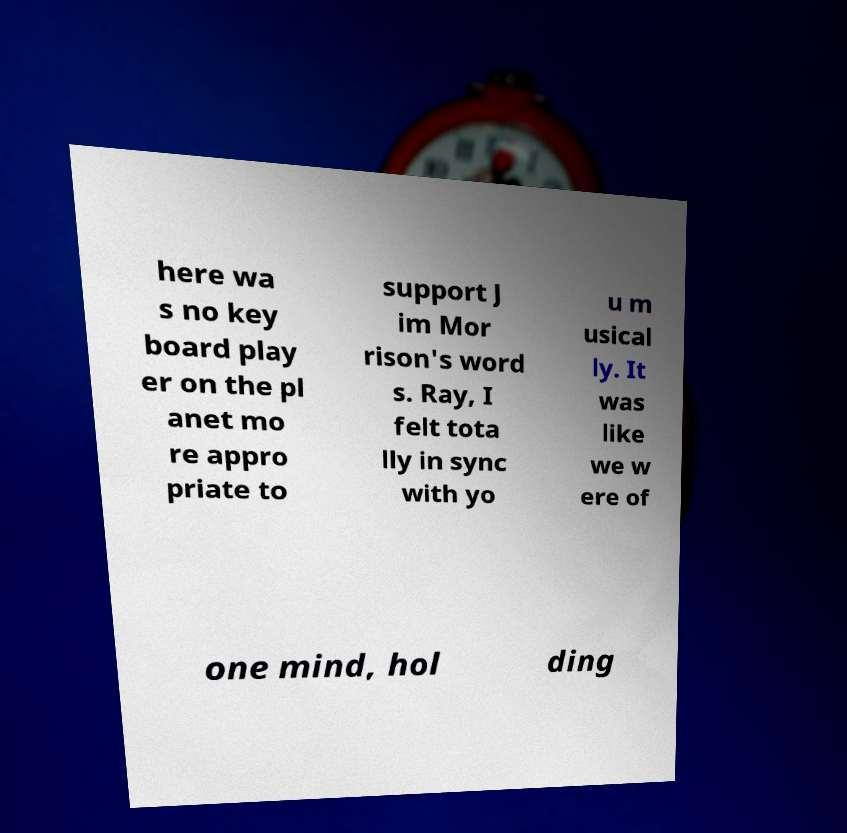Could you assist in decoding the text presented in this image and type it out clearly? here wa s no key board play er on the pl anet mo re appro priate to support J im Mor rison's word s. Ray, I felt tota lly in sync with yo u m usical ly. It was like we w ere of one mind, hol ding 